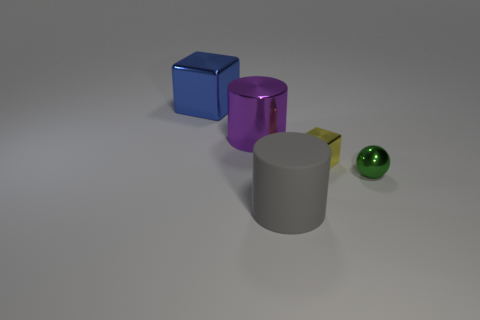There is a big metallic object that is right of the large metal block to the left of the large purple object; are there any objects to the right of it?
Provide a short and direct response. Yes. There is a thing that is both in front of the tiny shiny cube and left of the small block; what color is it?
Your answer should be very brief. Gray. There is a cylinder that is behind the small yellow thing; is it the same size as the cylinder that is in front of the small green metallic ball?
Your response must be concise. Yes. What color is the large cylinder that is behind the large thing that is in front of the large purple thing?
Provide a succinct answer. Purple. Are there fewer large blue things that are to the right of the large rubber cylinder than blue blocks on the right side of the green shiny thing?
Provide a succinct answer. No. There is a purple shiny cylinder; is it the same size as the metallic block that is on the right side of the blue shiny object?
Give a very brief answer. No. What shape is the thing that is both in front of the small yellow metal cube and left of the small metal cube?
Your answer should be very brief. Cylinder. There is a yellow object that is made of the same material as the small green thing; what size is it?
Keep it short and to the point. Small. How many small yellow blocks are in front of the small metal object to the left of the green metallic thing?
Offer a very short reply. 0. Is the material of the tiny object in front of the yellow thing the same as the large blue cube?
Provide a short and direct response. Yes. 